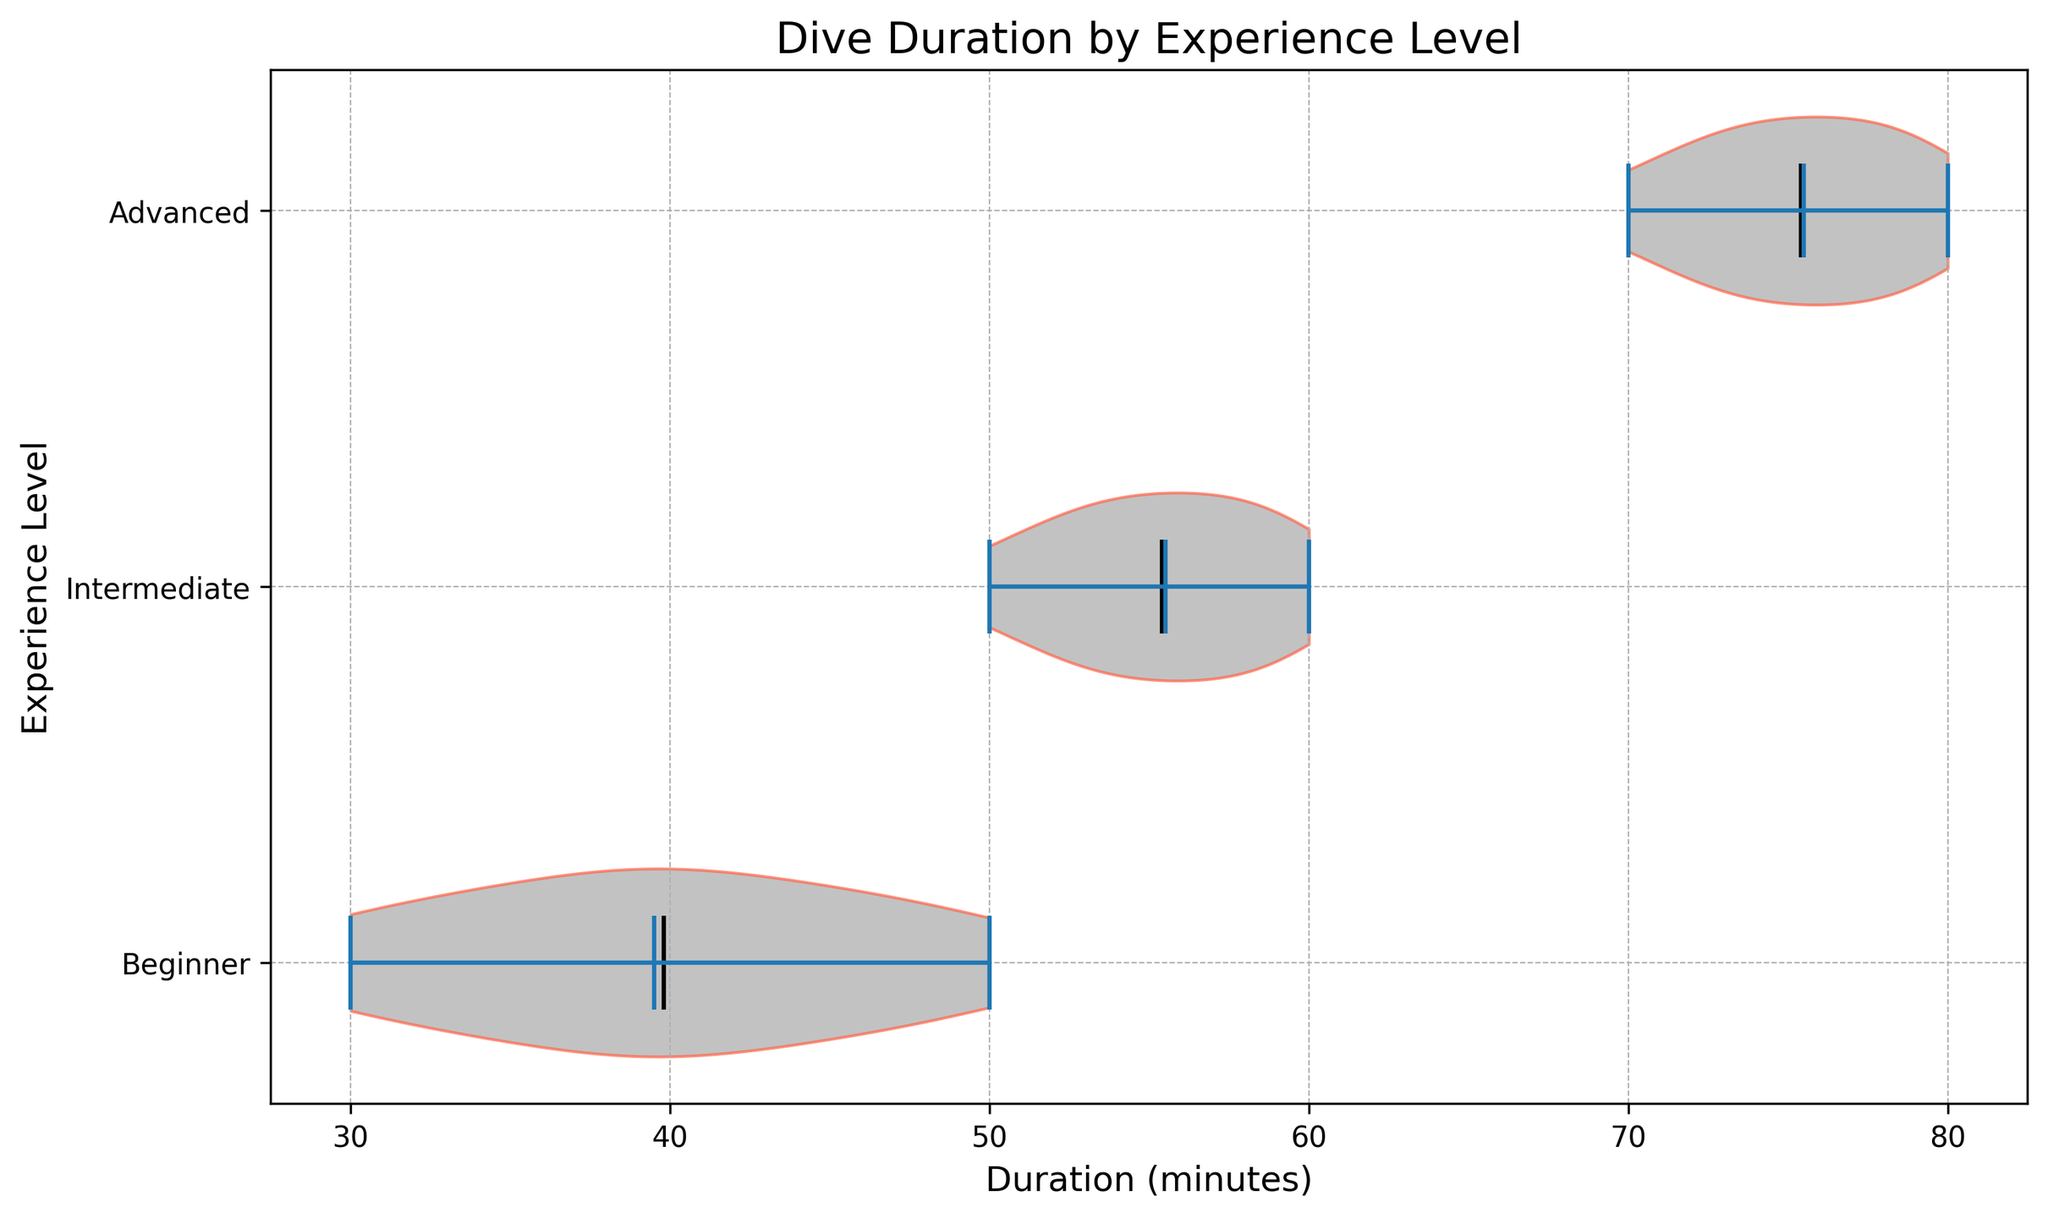Which experience level has the shortest median dive duration? The violin plot includes median lines marked visibly for each experience level. By observing these lines, you will notice the shortest median lies within the Beginner category.
Answer: Beginner How does the median dive duration for Intermediate divers compare to Advanced divers? By comparing the median lines on the violins for Intermediate and Advanced divers, it’s clear that the median duration for Advanced divers is greater than for Intermediate divers.
Answer: Advanced divers have a higher median duration By approximately how many minutes does the median dive duration of Advanced divers exceed that of Beginner divers? Identify the median lines for both Beginner and Advanced divers. Subtract the Beginner’s median duration from the Advanced’s median duration to find the difference. The median for Beginners is around 40 and for Advanced it is around 75, thus 75 - 40 is approximately 35 minutes.
Answer: Approximately 35 minutes What is the range of dive durations for Intermediate divers? The range can be determined by looking at the top and bottom of the violin plot for the Intermediate group. The lowest and highest durations visible are around 50 and 60 minutes respectively. Thus, the range is 60 - 50.
Answer: 10 minutes Are there any visible outliers in the dive durations for any of the experience levels? Observing the violin plots, any outliers would be shown as points outside the main body of the violin. Since there are no points markedly outside the main distributions, there are no obvious outliers.
Answer: No What is the difference in the mean dive duration between Beginner and Advanced divers? The violin plot shows a line for the mean for each category. By roughly estimating these lines, Beginners have a mean around 40, and Advanced divers around 75. Therefore, the difference is about 75 - 40.
Answer: Approximately 35 minutes Which experience level shows the most variability in dive durations? The most variability would be observed where the violin plot is widest. By comparing the widths of the violins, Advanced divers show the broadest spread, indicating the most variability.
Answer: Advanced How do the mean and median dive durations compare for Intermediate divers? Observe the lines marking the mean and median within the Intermediate violin. Both values are close, suggesting the distribution is relatively symmetric. The plotted positions show both around 55-57 minutes.
Answer: They are very close Which experience level has the longest dive duration? The longest dive duration can be observed at the far right tip of the violin plots. The rightmost extending part of the Advanced divers' violin reaches the highest duration of around 80 minutes.
Answer: Advanced In what way is the distribution of dive durations for Beginner divers different from that of Intermediate divers? Observe the shapes of the violins. Beginner divers' plot is narrower and more symmetric, indicating less variability and more concentrated durations, while Intermediate divers' plot is wider and less symmetric, pointing to more variability.
Answer: Less variable and more symmetric in Beginners compared to Intermediates 